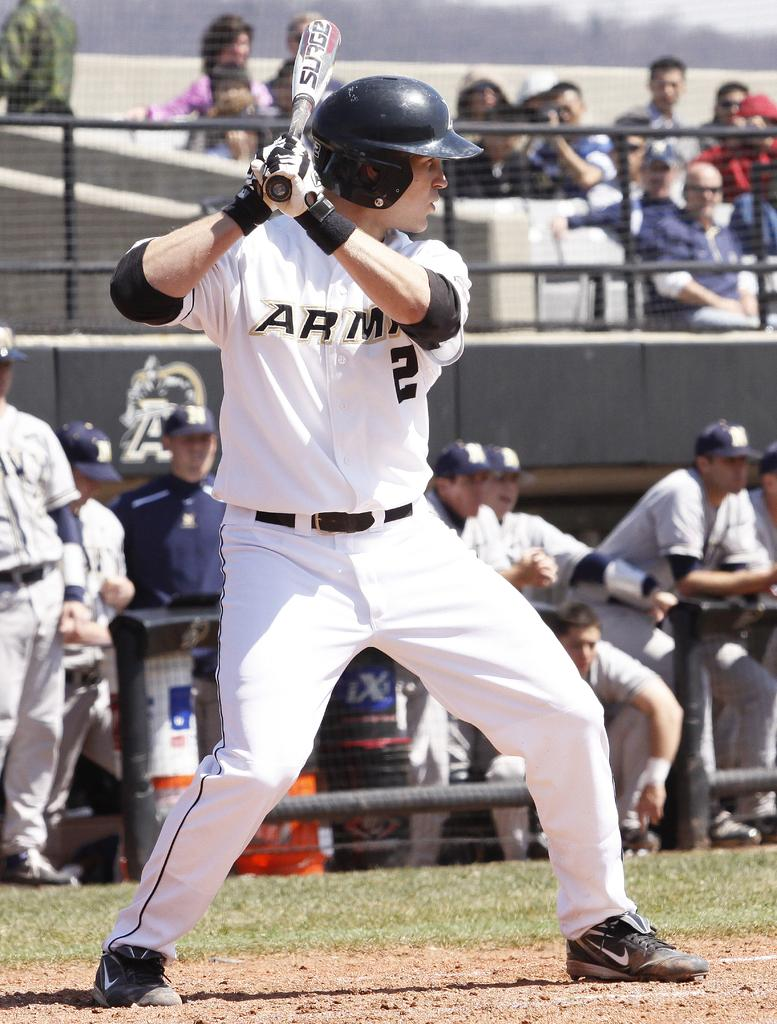Provide a one-sentence caption for the provided image. A professional baseball player holds his bat and intently waits for the pitch. 